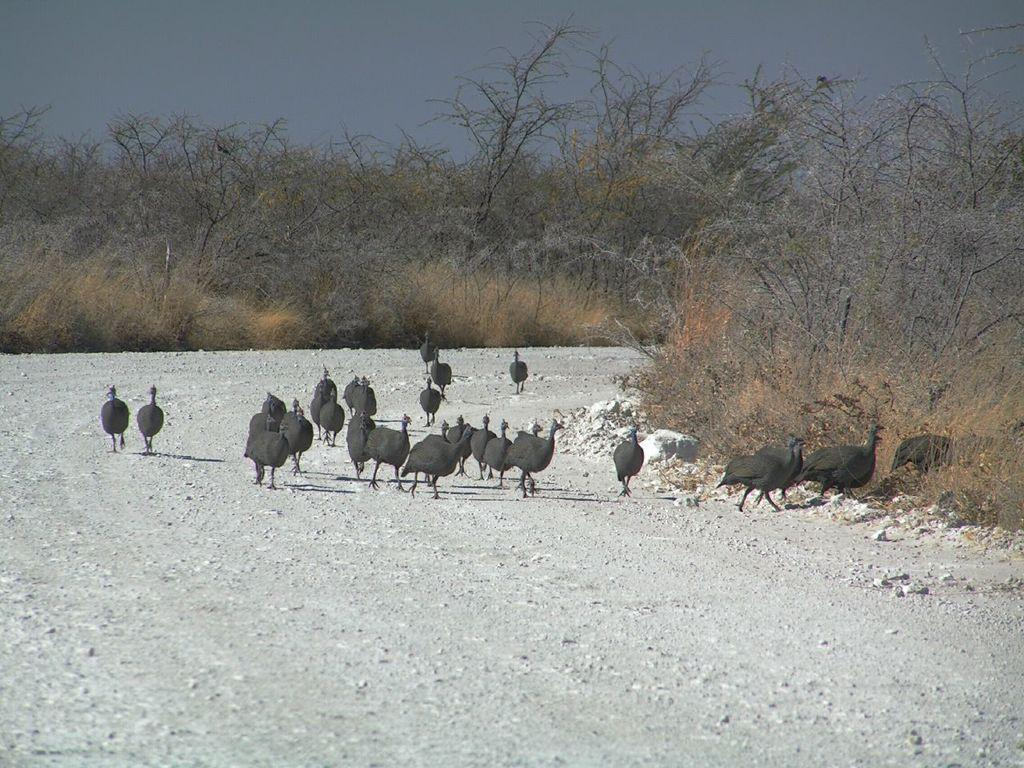Where was the picture taken? The picture was clicked outside. What is the main subject of the image? There is a group of birds in the center of the image. What are the birds doing in the image? The birds appear to be running on the ground. What can be seen in the background of the image? There are dry stems and the sky visible in the background. What type of apparel is the bird wearing on its knee in the image? There is no bird wearing apparel or showing a knee in the image; the birds are running on the ground. Can you tell me how much milk the birds are drinking in the image? There is no milk present in the image; the birds are running on the ground. 